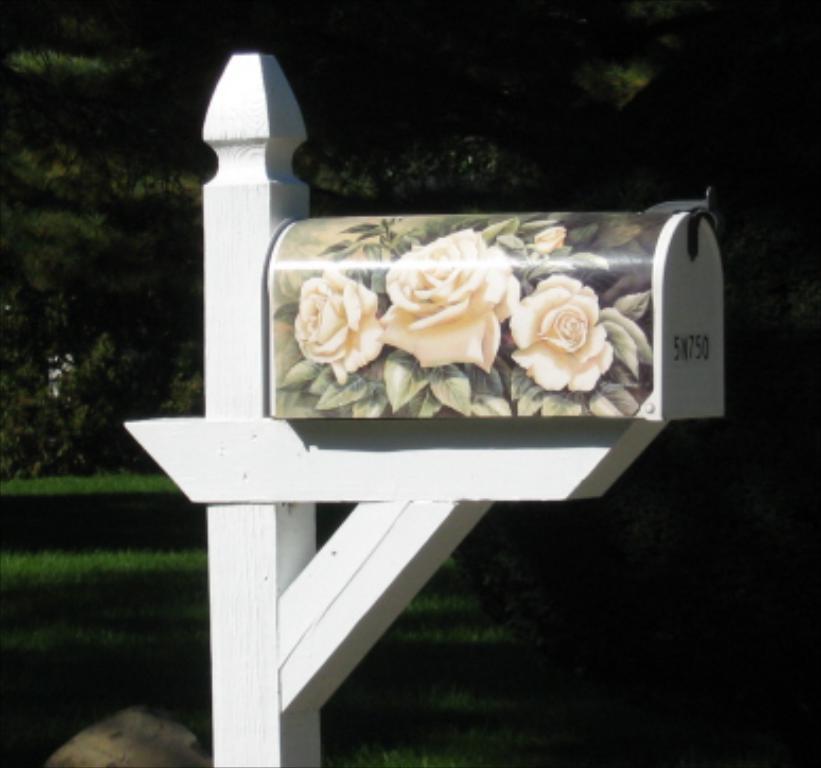Could you give a brief overview of what you see in this image? Here we can see a wooden box with flowers poster on it on a wooden platform. In the background there are trees and grass. 